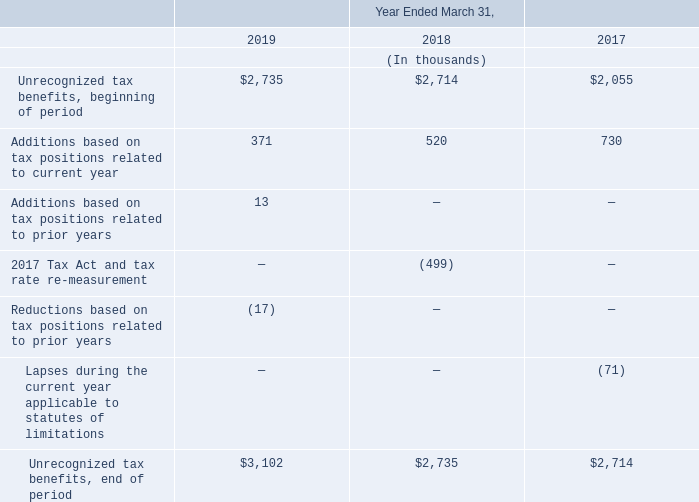The long-term portion of the Company’s unrecognized tax benefits at March 31, 2019 and 2018 was $622,000 and $619,000, respectively, of which the timing of the resolution is uncertain. As of March 31, 2019 and 2018, $2.5 million and $2.1 million, respectively, of unrecognized tax benefits had been recorded as a reduction to net deferred tax assets.
As of March 31, 2019, the Company’s net deferred tax assets of $6.7 million are subject to a valuation allowance of $6.7 million. It is possible, however, that some months or years may elapse before an uncertain position for which the Company has established a reserve is resolved. A reconciliation of unrecognized tax benefits is as follows:
The unrecognized tax benefit balance as of March 31, 2019 of $599,000 would affect the Company’s effective tax rate if recognized.
What was the long term portion of the unrecognized tax benefits in 2019 and 2018 respectively? $622,000, $619,000. What was the net deferred tax assets in 2019? $6.7 million. What was the Unrecognized tax benefits, beginning of period in 2019?
Answer scale should be: thousand. $2,735. In which year was Additions based on tax positions related to current year less than 600 thousands? Locate and analyze additions based on tax positions related to current year in row 5
answer: 2019, 2018. What is the average Additions based on tax positions related to prior years between 2017-2019?
Answer scale should be: thousand. (13 + 0 + 0) / 3
Answer: 4.33. What was the change in the Unrecognized tax benefits, end of period from 2018 to 2019?
Answer scale should be: thousand. 3,102 - 2,735
Answer: 367. 